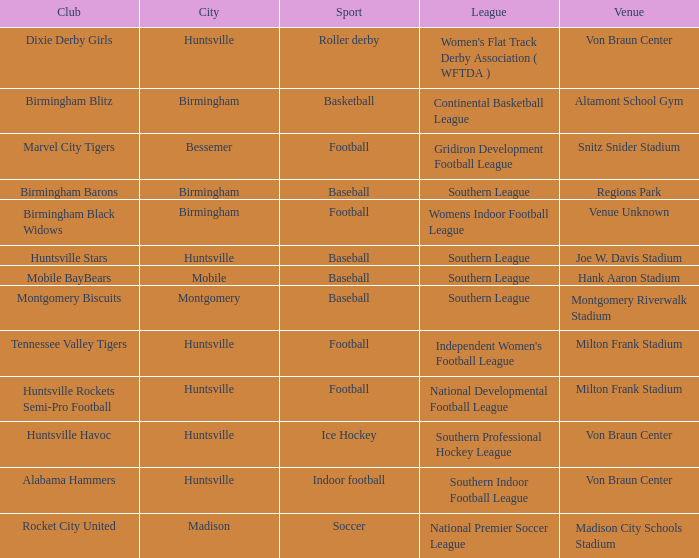Which venue hosted the Dixie Derby Girls? Von Braun Center. 